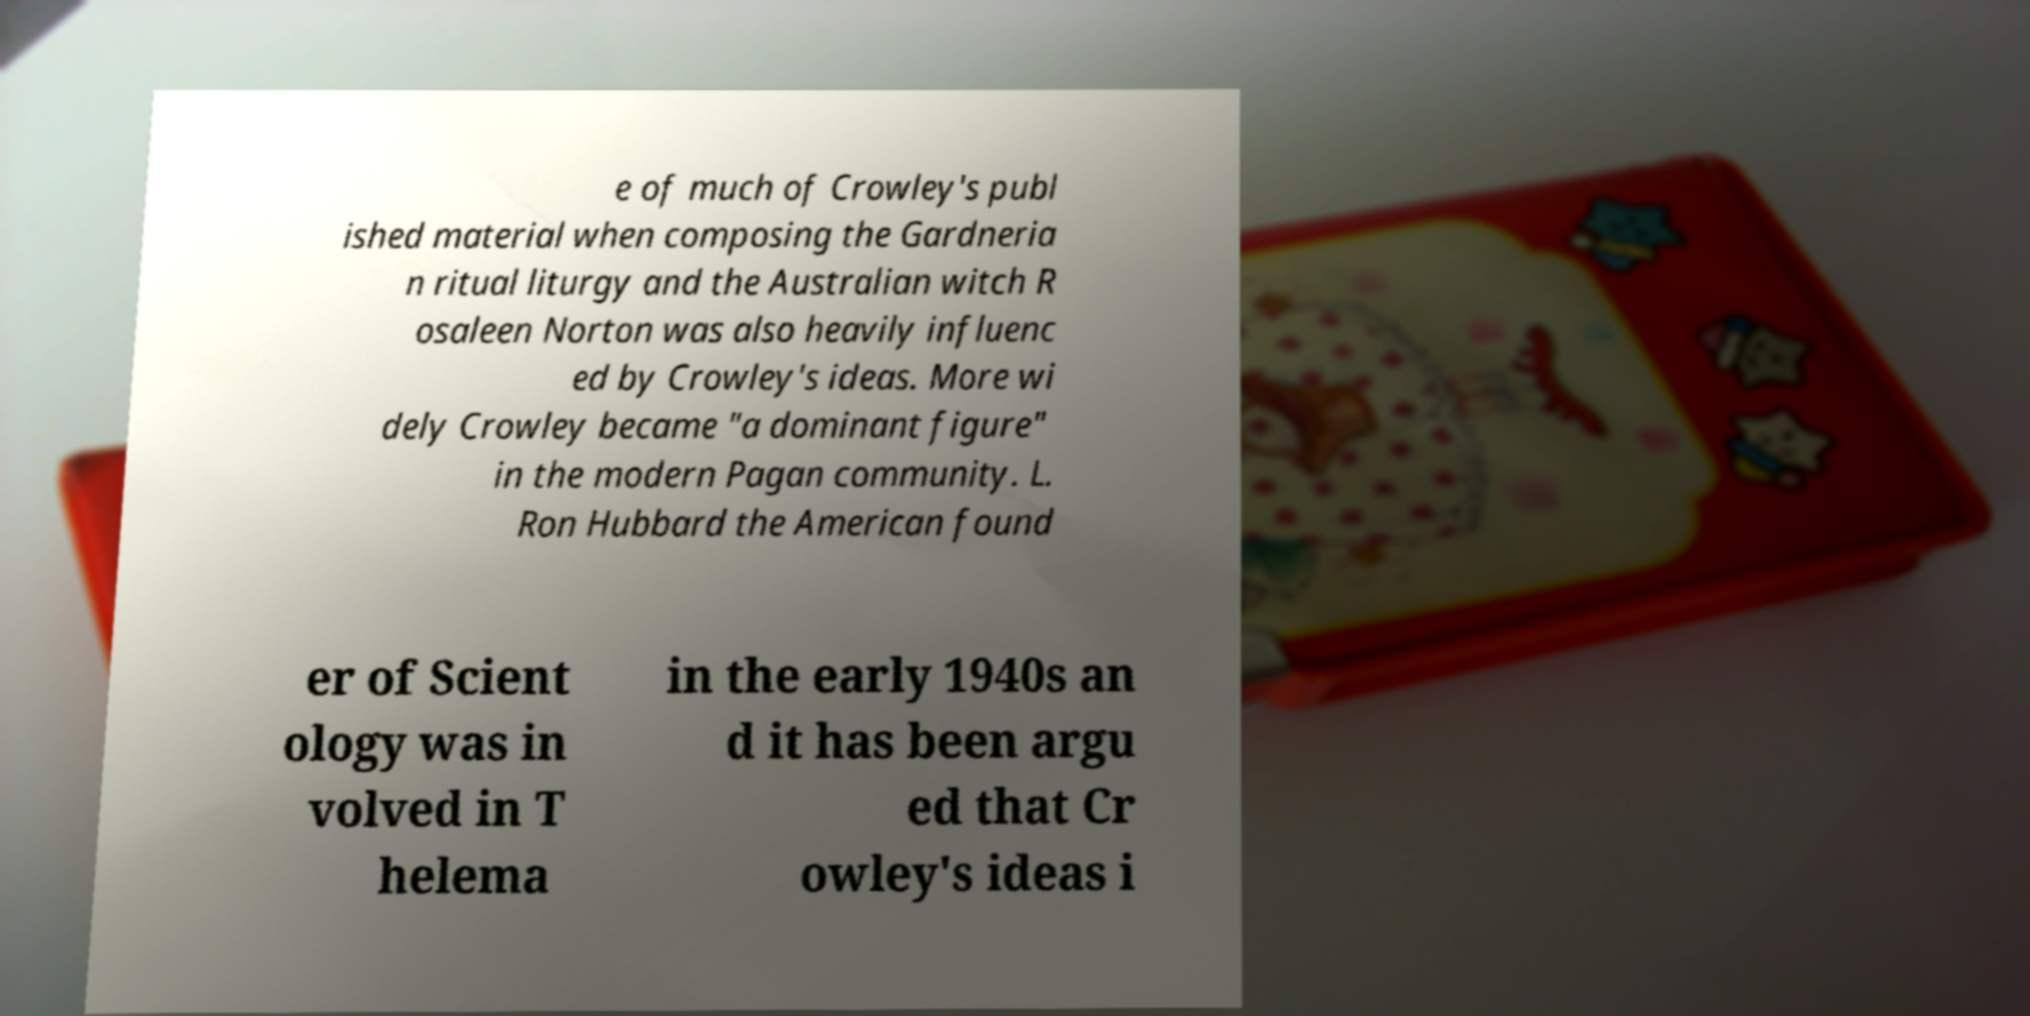For documentation purposes, I need the text within this image transcribed. Could you provide that? e of much of Crowley's publ ished material when composing the Gardneria n ritual liturgy and the Australian witch R osaleen Norton was also heavily influenc ed by Crowley's ideas. More wi dely Crowley became "a dominant figure" in the modern Pagan community. L. Ron Hubbard the American found er of Scient ology was in volved in T helema in the early 1940s an d it has been argu ed that Cr owley's ideas i 